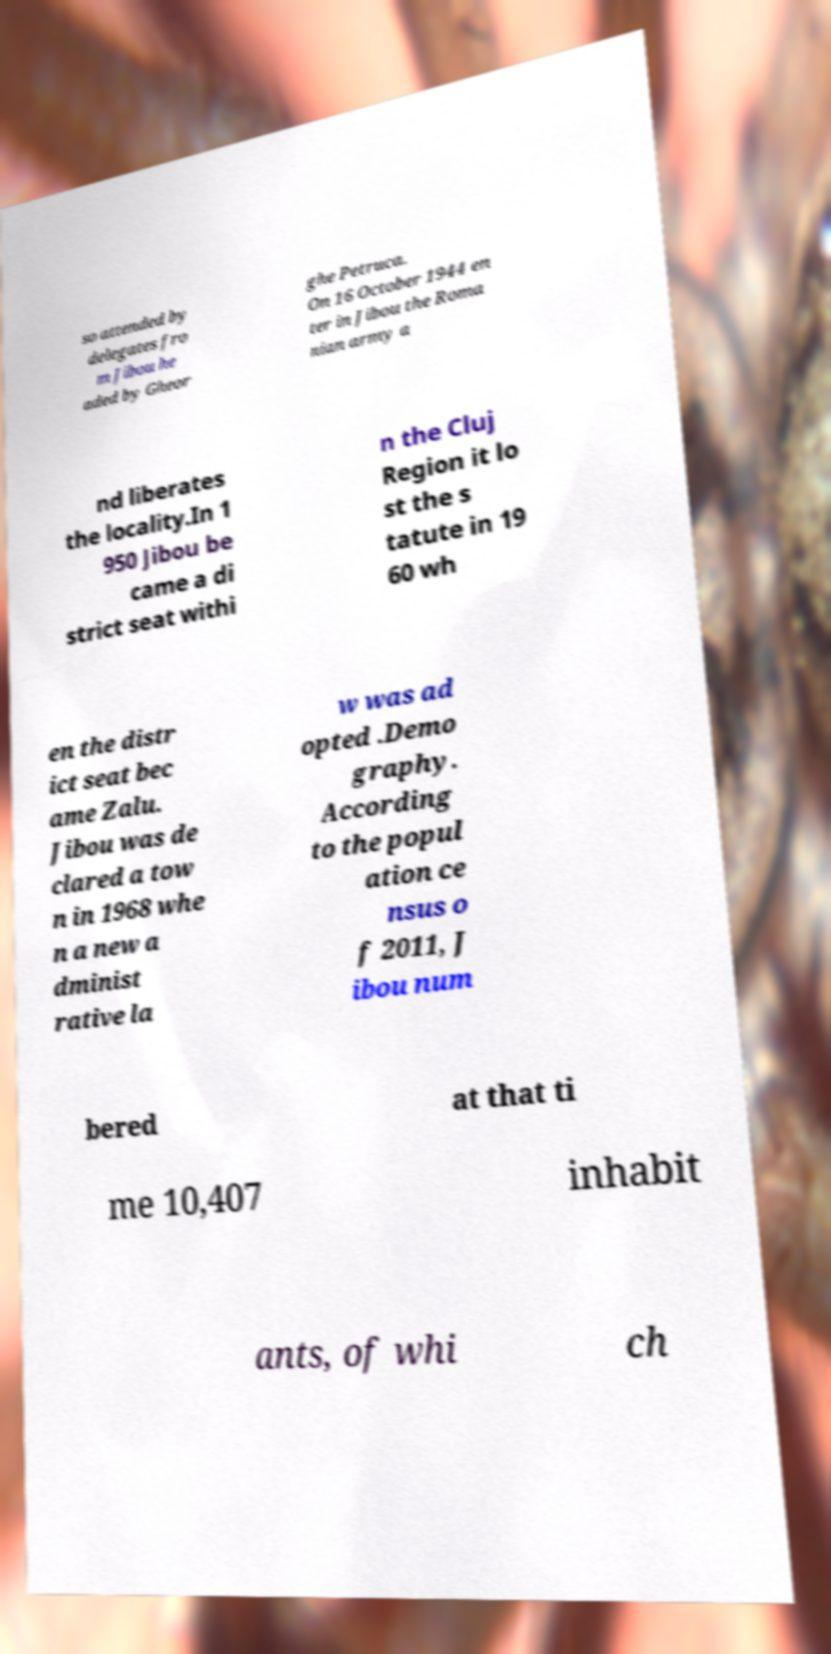For documentation purposes, I need the text within this image transcribed. Could you provide that? so attended by delegates fro m Jibou he aded by Gheor ghe Petruca. On 16 October 1944 en ter in Jibou the Roma nian army a nd liberates the locality.In 1 950 Jibou be came a di strict seat withi n the Cluj Region it lo st the s tatute in 19 60 wh en the distr ict seat bec ame Zalu. Jibou was de clared a tow n in 1968 whe n a new a dminist rative la w was ad opted .Demo graphy. According to the popul ation ce nsus o f 2011, J ibou num bered at that ti me 10,407 inhabit ants, of whi ch 